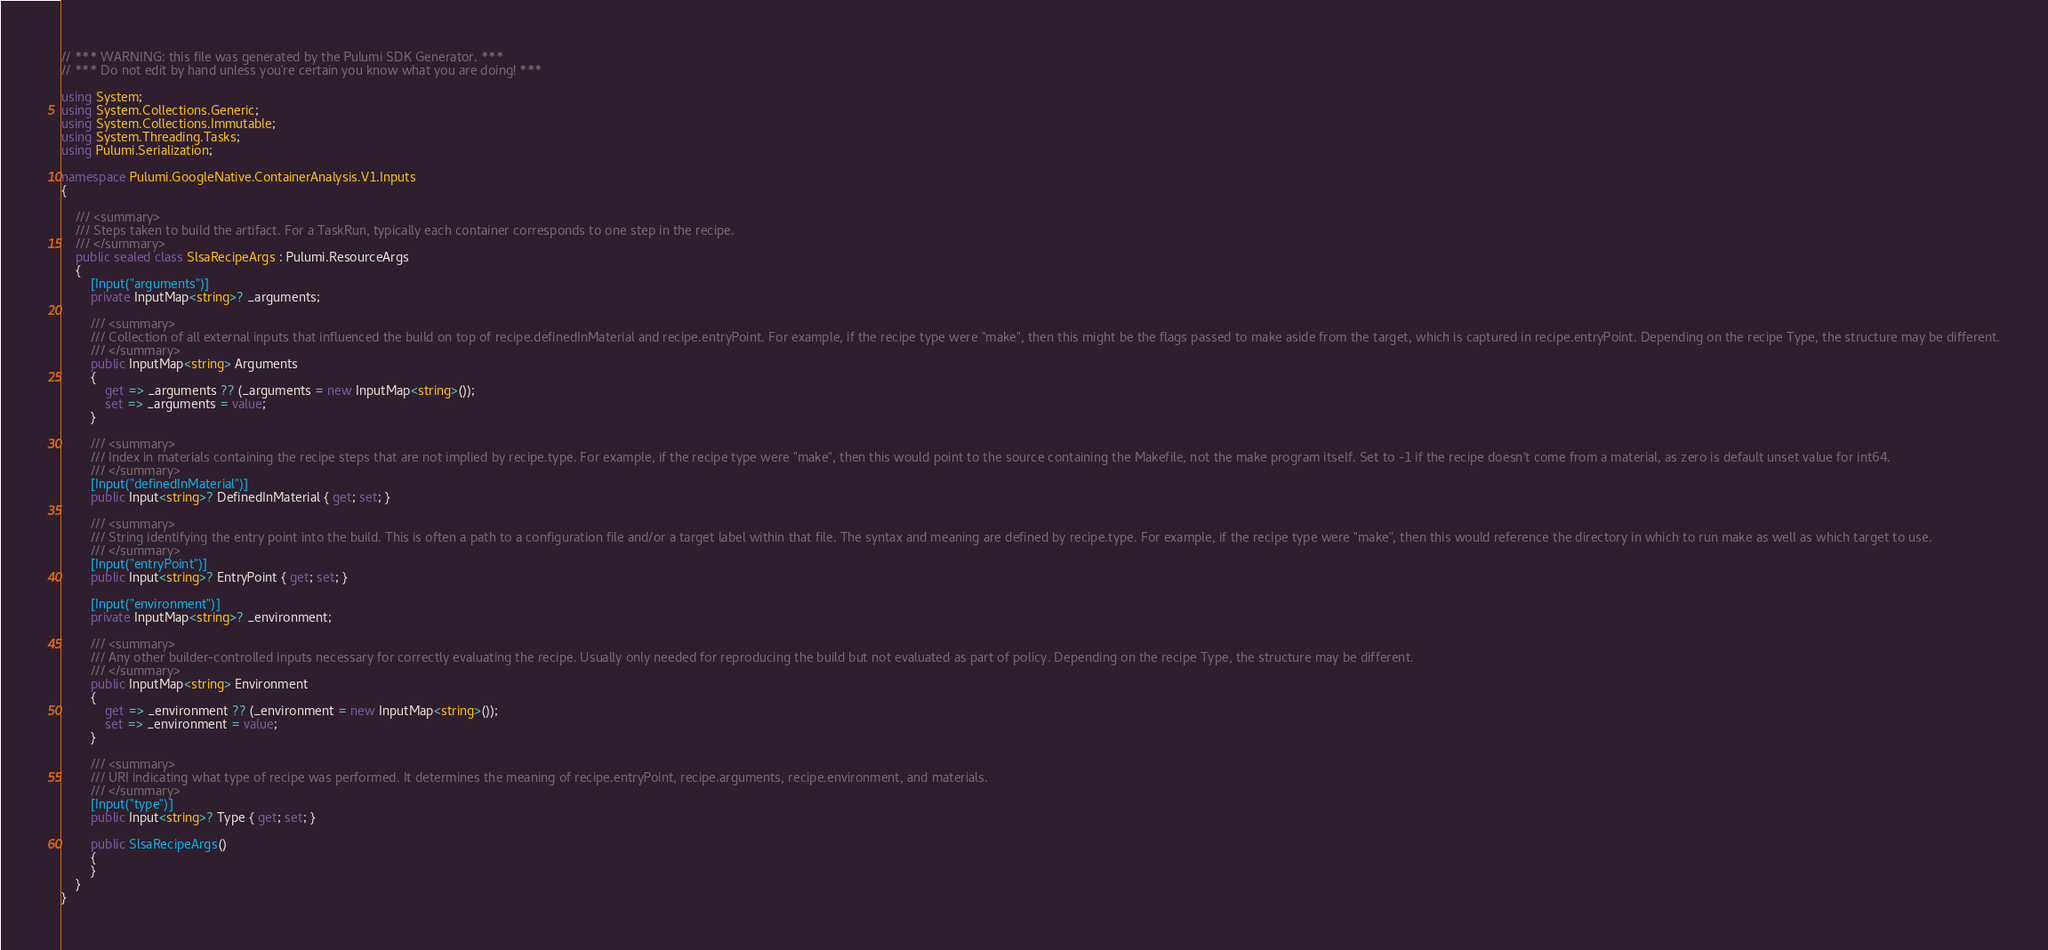Convert code to text. <code><loc_0><loc_0><loc_500><loc_500><_C#_>// *** WARNING: this file was generated by the Pulumi SDK Generator. ***
// *** Do not edit by hand unless you're certain you know what you are doing! ***

using System;
using System.Collections.Generic;
using System.Collections.Immutable;
using System.Threading.Tasks;
using Pulumi.Serialization;

namespace Pulumi.GoogleNative.ContainerAnalysis.V1.Inputs
{

    /// <summary>
    /// Steps taken to build the artifact. For a TaskRun, typically each container corresponds to one step in the recipe.
    /// </summary>
    public sealed class SlsaRecipeArgs : Pulumi.ResourceArgs
    {
        [Input("arguments")]
        private InputMap<string>? _arguments;

        /// <summary>
        /// Collection of all external inputs that influenced the build on top of recipe.definedInMaterial and recipe.entryPoint. For example, if the recipe type were "make", then this might be the flags passed to make aside from the target, which is captured in recipe.entryPoint. Depending on the recipe Type, the structure may be different.
        /// </summary>
        public InputMap<string> Arguments
        {
            get => _arguments ?? (_arguments = new InputMap<string>());
            set => _arguments = value;
        }

        /// <summary>
        /// Index in materials containing the recipe steps that are not implied by recipe.type. For example, if the recipe type were "make", then this would point to the source containing the Makefile, not the make program itself. Set to -1 if the recipe doesn't come from a material, as zero is default unset value for int64.
        /// </summary>
        [Input("definedInMaterial")]
        public Input<string>? DefinedInMaterial { get; set; }

        /// <summary>
        /// String identifying the entry point into the build. This is often a path to a configuration file and/or a target label within that file. The syntax and meaning are defined by recipe.type. For example, if the recipe type were "make", then this would reference the directory in which to run make as well as which target to use.
        /// </summary>
        [Input("entryPoint")]
        public Input<string>? EntryPoint { get; set; }

        [Input("environment")]
        private InputMap<string>? _environment;

        /// <summary>
        /// Any other builder-controlled inputs necessary for correctly evaluating the recipe. Usually only needed for reproducing the build but not evaluated as part of policy. Depending on the recipe Type, the structure may be different.
        /// </summary>
        public InputMap<string> Environment
        {
            get => _environment ?? (_environment = new InputMap<string>());
            set => _environment = value;
        }

        /// <summary>
        /// URI indicating what type of recipe was performed. It determines the meaning of recipe.entryPoint, recipe.arguments, recipe.environment, and materials.
        /// </summary>
        [Input("type")]
        public Input<string>? Type { get; set; }

        public SlsaRecipeArgs()
        {
        }
    }
}
</code> 